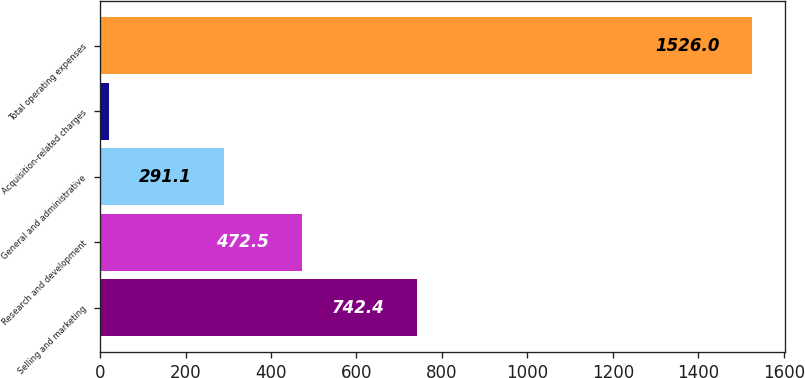Convert chart. <chart><loc_0><loc_0><loc_500><loc_500><bar_chart><fcel>Selling and marketing<fcel>Research and development<fcel>General and administrative<fcel>Acquisition-related charges<fcel>Total operating expenses<nl><fcel>742.4<fcel>472.5<fcel>291.1<fcel>20<fcel>1526<nl></chart> 